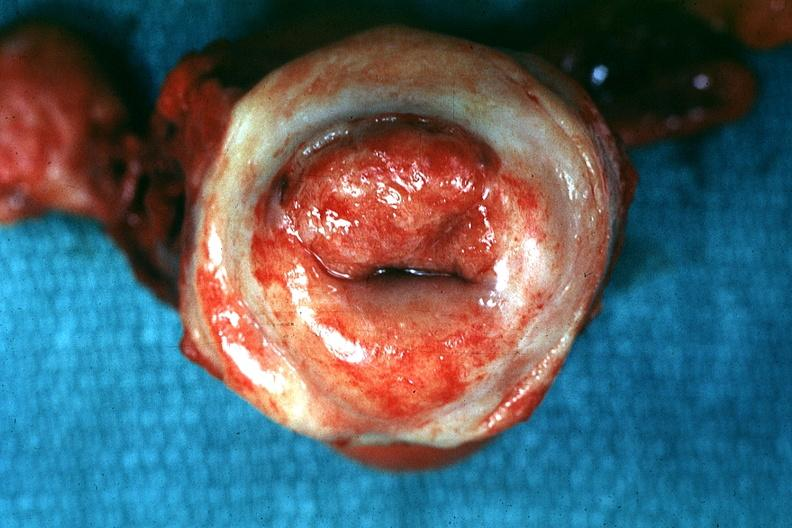s malignant adenoma said to be invasive carcinoma?
Answer the question using a single word or phrase. No 